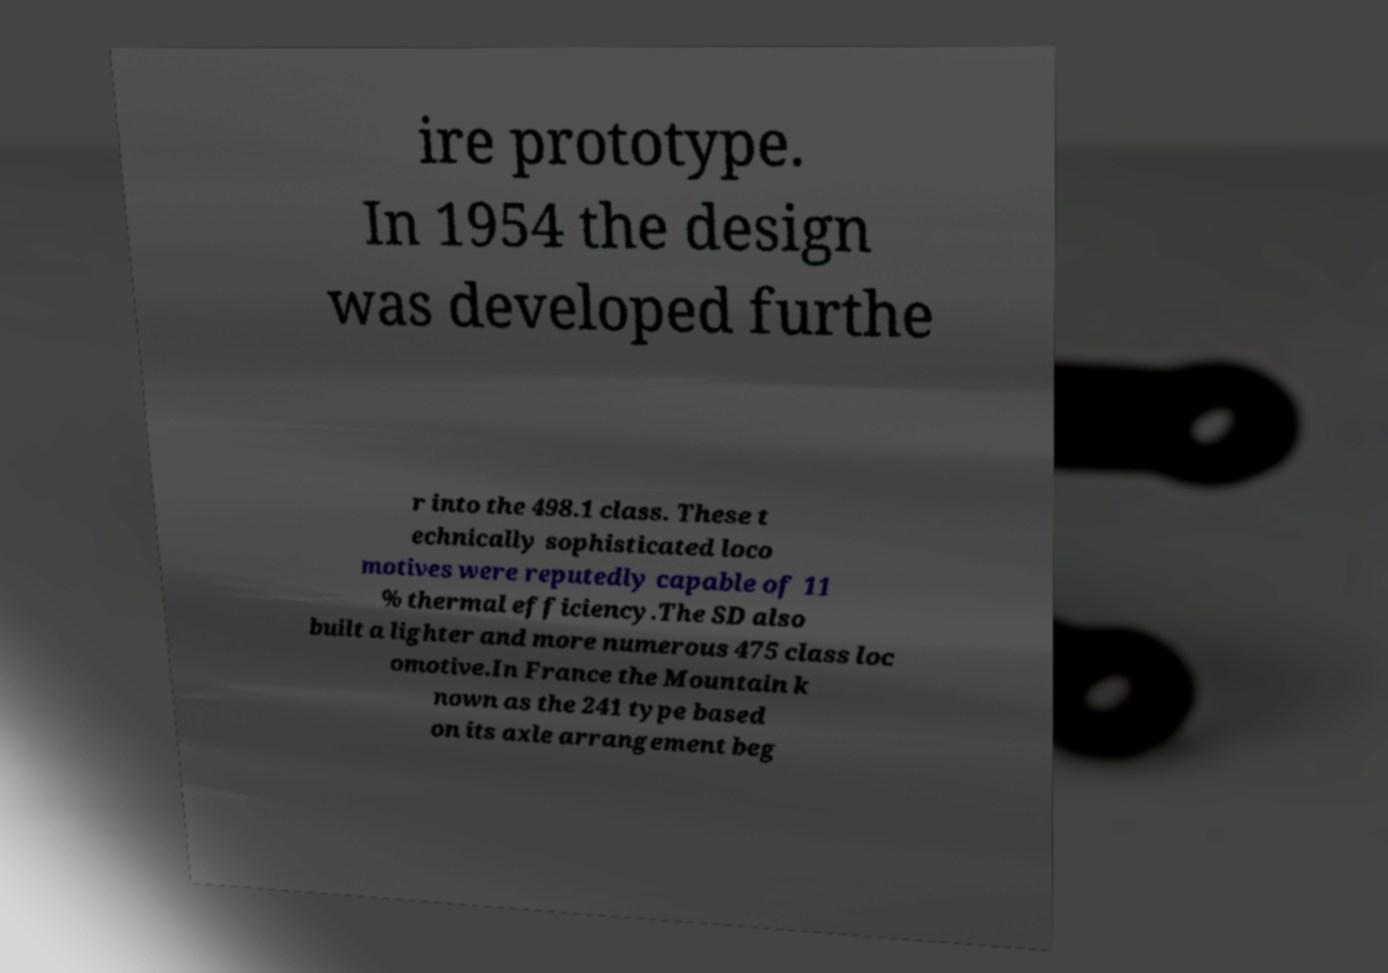Please identify and transcribe the text found in this image. ire prototype. In 1954 the design was developed furthe r into the 498.1 class. These t echnically sophisticated loco motives were reputedly capable of 11 % thermal efficiency.The SD also built a lighter and more numerous 475 class loc omotive.In France the Mountain k nown as the 241 type based on its axle arrangement beg 